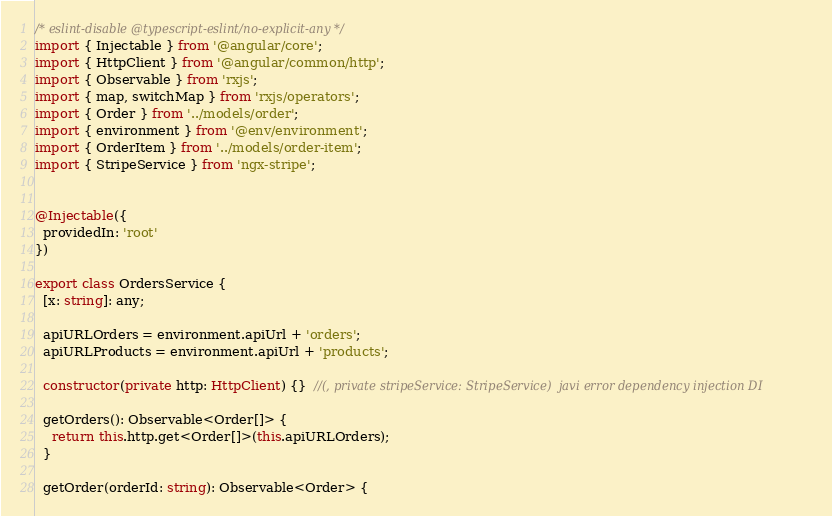<code> <loc_0><loc_0><loc_500><loc_500><_TypeScript_>/* eslint-disable @typescript-eslint/no-explicit-any */
import { Injectable } from '@angular/core';
import { HttpClient } from '@angular/common/http';
import { Observable } from 'rxjs';
import { map, switchMap } from 'rxjs/operators';
import { Order } from '../models/order';
import { environment } from '@env/environment';
import { OrderItem } from '../models/order-item';
import { StripeService } from 'ngx-stripe';


@Injectable({
  providedIn: 'root'
})

export class OrdersService {
  [x: string]: any;

  apiURLOrders = environment.apiUrl + 'orders';
  apiURLProducts = environment.apiUrl + 'products';

  constructor(private http: HttpClient) {}  //(, private stripeService: StripeService)  javi error dependency injection DI

  getOrders(): Observable<Order[]> {
    return this.http.get<Order[]>(this.apiURLOrders);
  }

  getOrder(orderId: string): Observable<Order> {</code> 